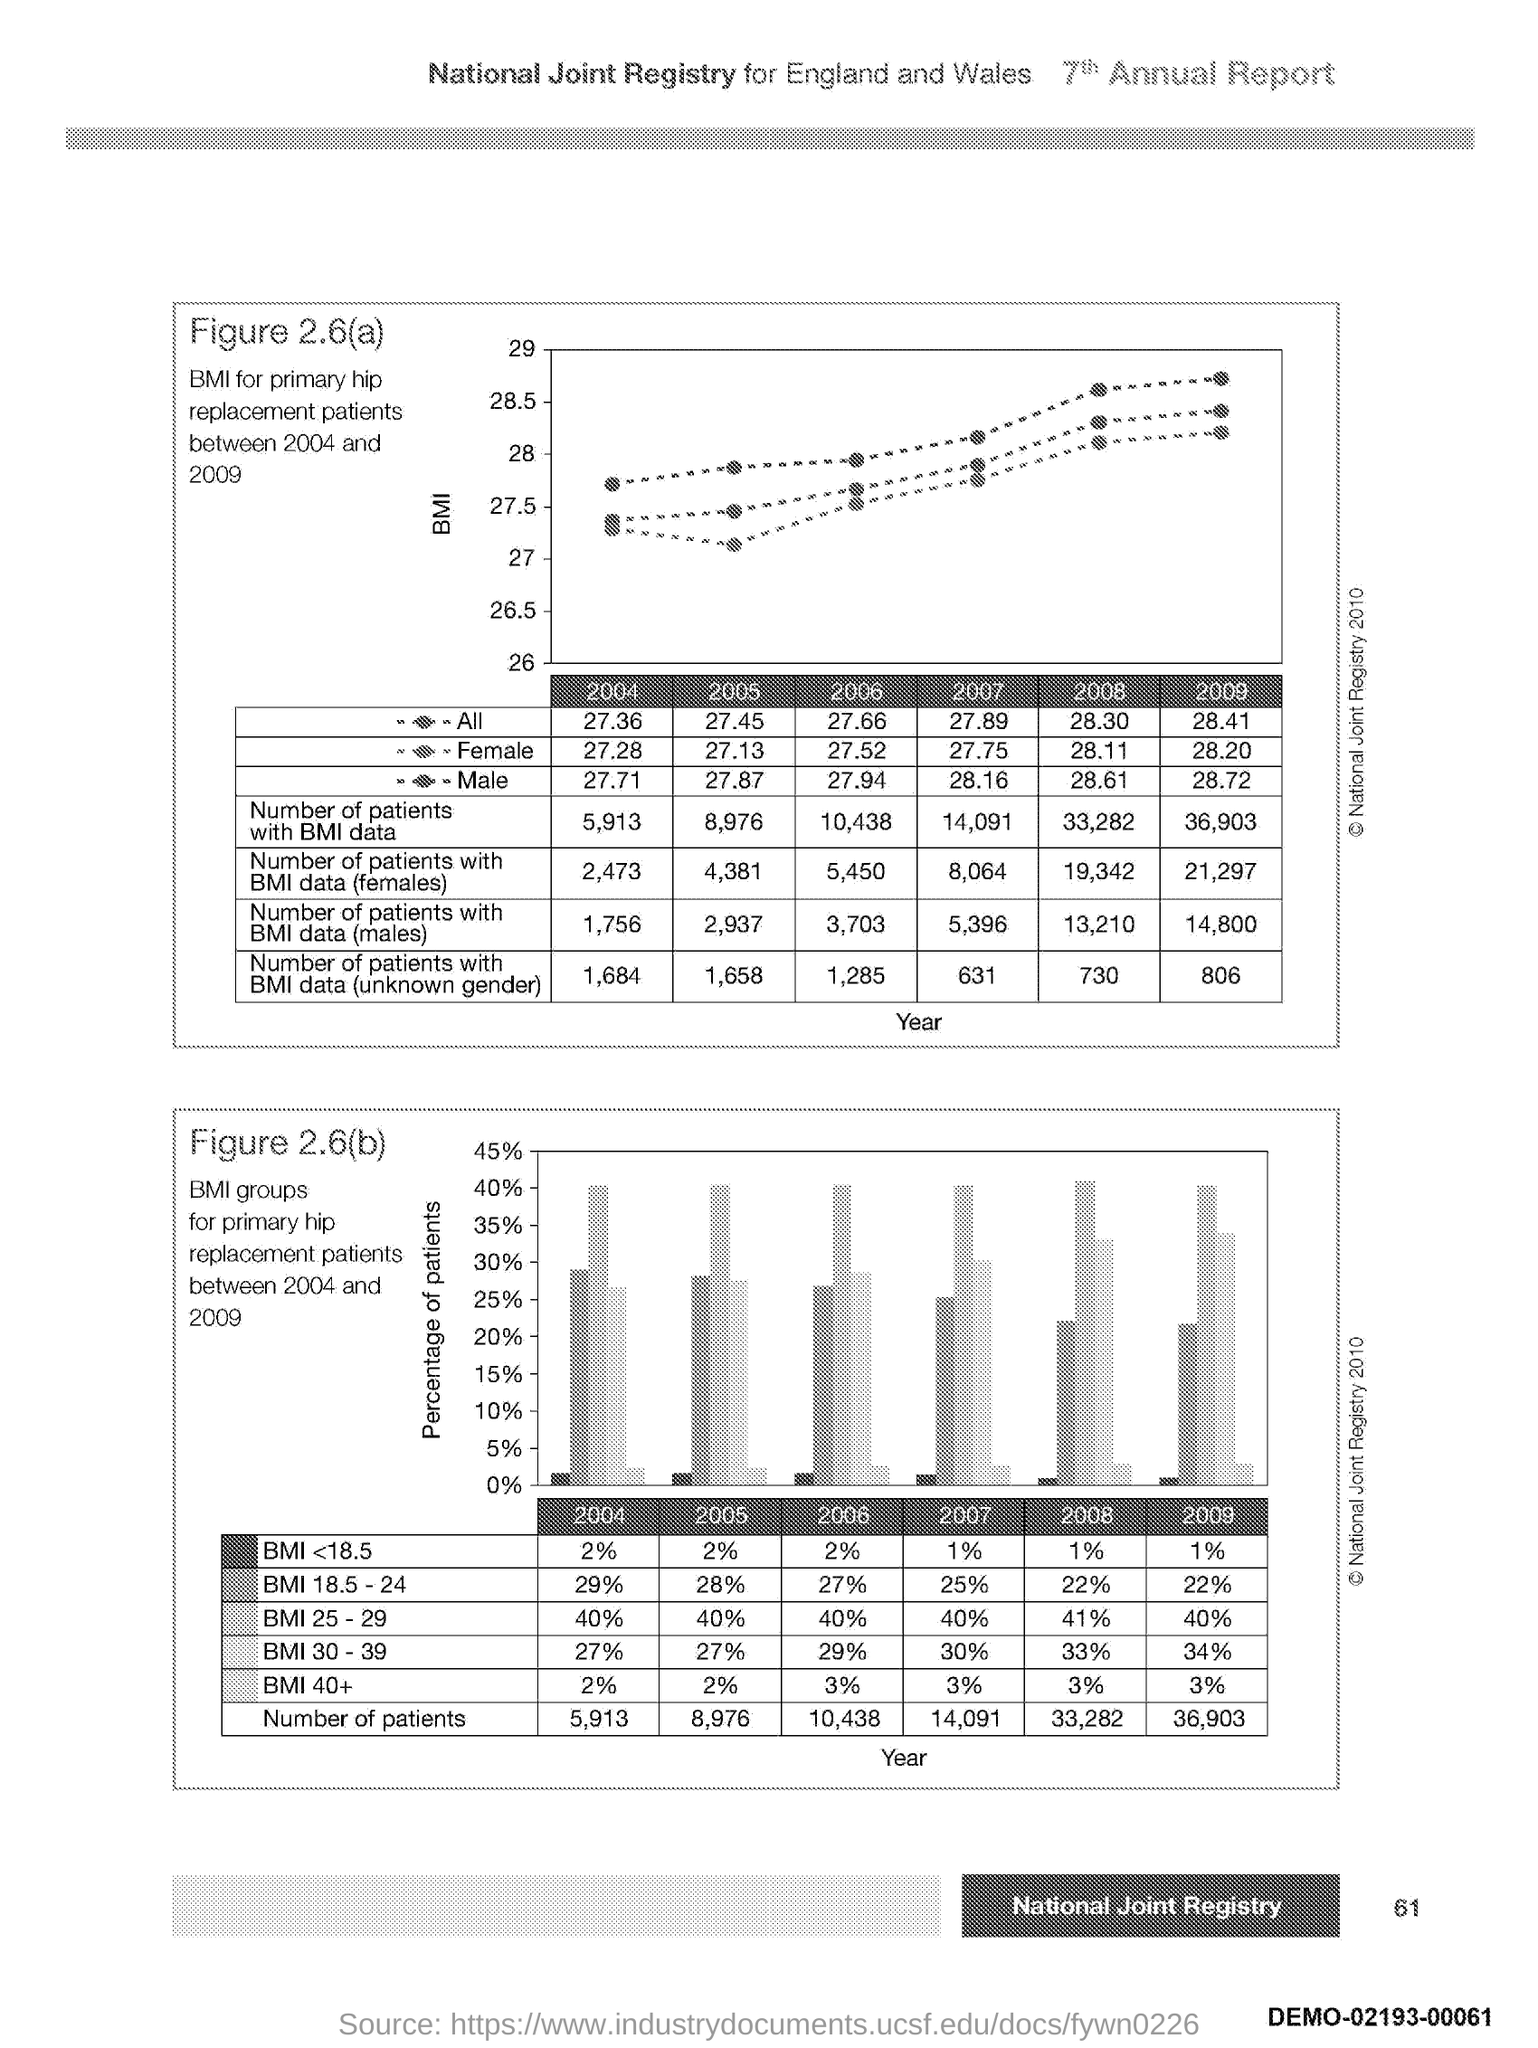Point out several critical features in this image. The second graph plots the percentage of patients as the y-axis, showing the proportion of patients who received the drug or the placebo in each treatment group. The y-axis of the first graph shows the Body Mass Index (BMI) values plotted on it. The x-axis of both graphs plots the year. 